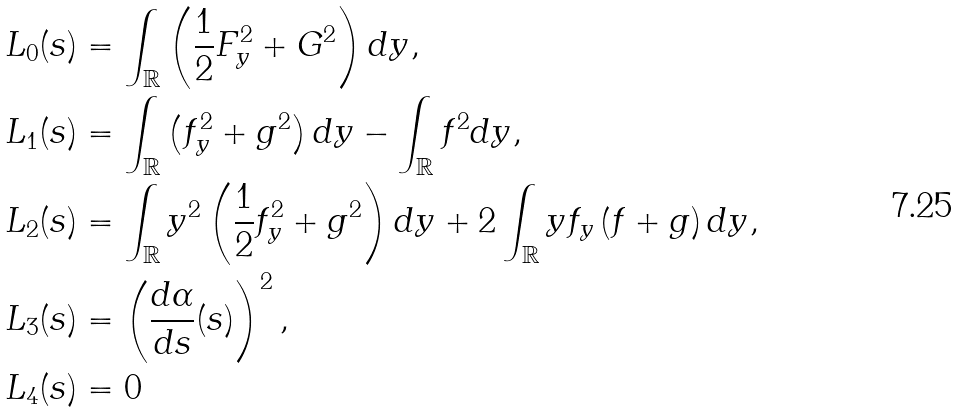Convert formula to latex. <formula><loc_0><loc_0><loc_500><loc_500>L _ { 0 } ( s ) & = \int _ { \mathbb { R } } \left ( \frac { 1 } { 2 } F _ { y } ^ { 2 } + G ^ { 2 } \right ) d y , \\ L _ { 1 } ( s ) & = \int _ { \mathbb { R } } \left ( f _ { y } ^ { 2 } + g ^ { 2 } \right ) d y - \int _ { \mathbb { R } } f ^ { 2 } d y , \\ L _ { 2 } ( s ) & = \int _ { \mathbb { R } } y ^ { 2 } \left ( \frac { 1 } { 2 } f _ { y } ^ { 2 } + g ^ { 2 } \right ) d y + 2 \int _ { \mathbb { R } } y f _ { y } \left ( f + g \right ) d y , \\ L _ { 3 } ( s ) & = \left ( \frac { d \alpha } { d s } ( s ) \right ) ^ { 2 } , \\ L _ { 4 } ( s ) & = 0</formula> 